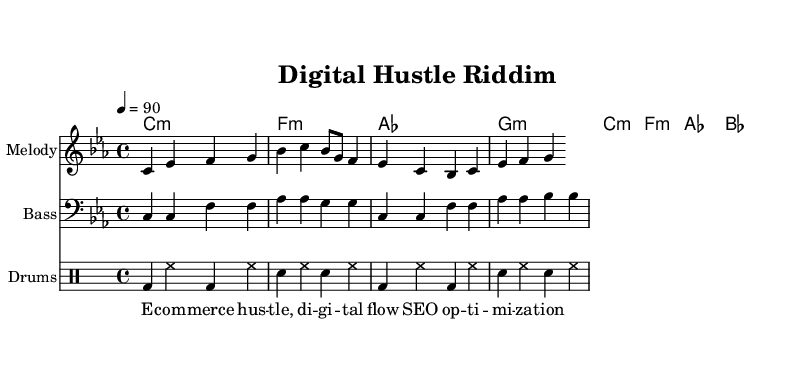What is the key signature of this music? The key signature is C minor, indicated by three flat symbols (B♭, E♭, A♭) shown at the beginning of the staff.
Answer: C minor What is the time signature of this music? The time signature is indicated as 4/4, which means there are four beats per measure and a quarter note gets one beat.
Answer: 4/4 What is the tempo marking of this music? The tempo marking indicates a speed of quarter note = 90 beats per minute, found at the beginning of the score.
Answer: 90 What is the first chord in this piece? The first chord is C minor, which is represented at the start of the chord names at the beginning of the piece.
Answer: C:m Which instrument is indicated to play the melody? The staff labeled "Melody" is indicated to play the melody line throughout the sheet music.
Answer: Melody How many measures are in the melody? By counting the bar lines in the melody section of the sheet music, one can find there are a total of four measures displayed.
Answer: 4 What aspect of modern business does the lyric reference? The lyrics mention "SEO optimization," which is related to digital marketing strategies in modern business.
Answer: SEO optimization 